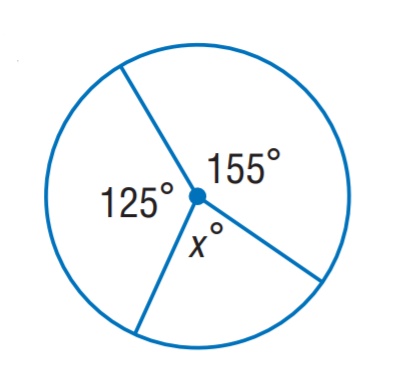Answer the mathemtical geometry problem and directly provide the correct option letter.
Question: Find x.
Choices: A: 60 B: 80 C: 125 D: 155 B 